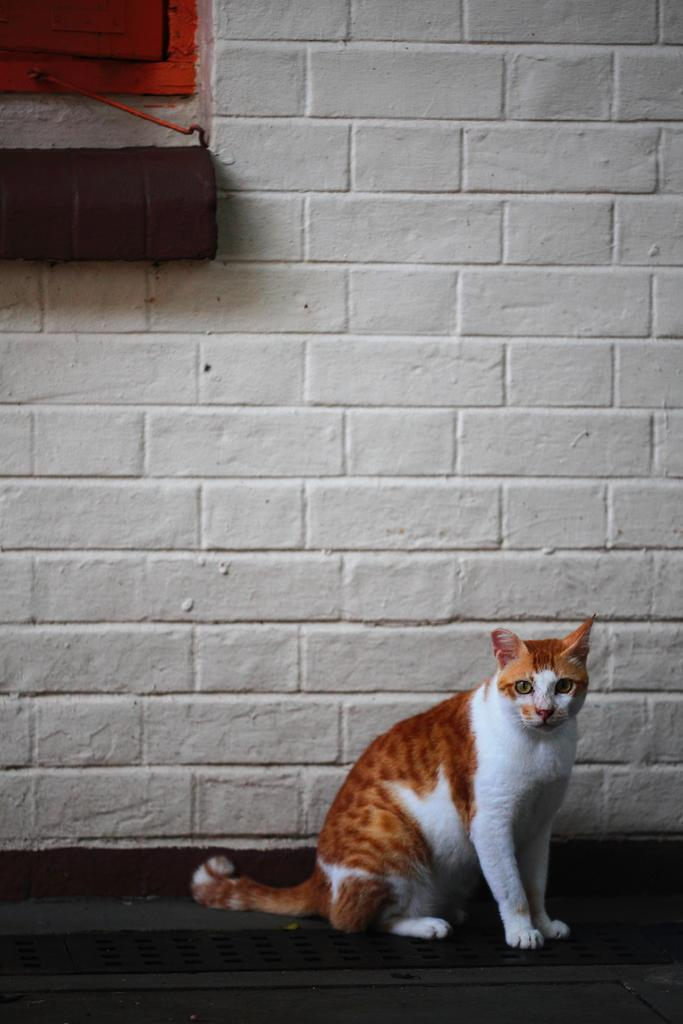What type of animal can be seen in the image? There is a cat in the image. Where is the cat located in the image? The cat is sitting on the floor. What is present on the wall in the image? There is a window and an object visible on the wall. What type of division is being performed by the cat in the image? There is no division being performed by the cat in the image; it is simply sitting on the floor. 